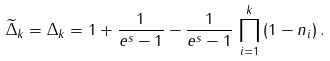Convert formula to latex. <formula><loc_0><loc_0><loc_500><loc_500>\widetilde { \Delta } _ { k } = \Delta _ { k } = 1 + \frac { 1 } { e ^ { s } - 1 } - \frac { 1 } { e ^ { s } - 1 } \, \prod _ { i = 1 } ^ { k } \, ( 1 - n _ { i } ) \, .</formula> 